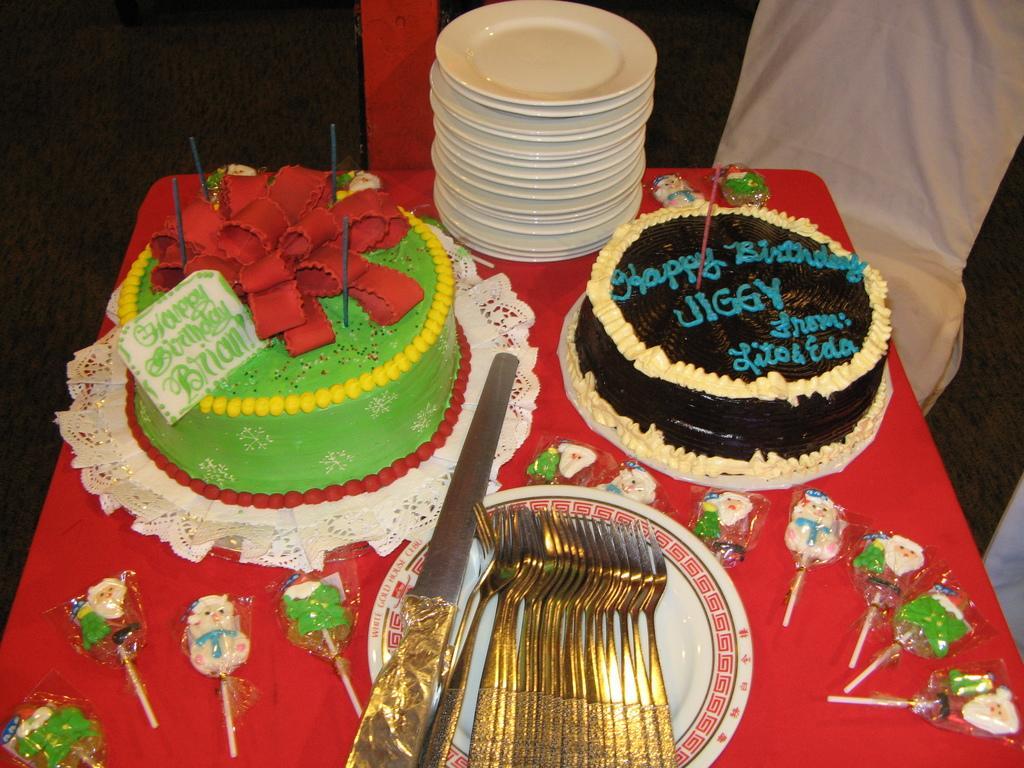Describe this image in one or two sentences. In the left side it is a green color cake, in the right side it is a black color cake, in the middle there are forks in a white color plate. 